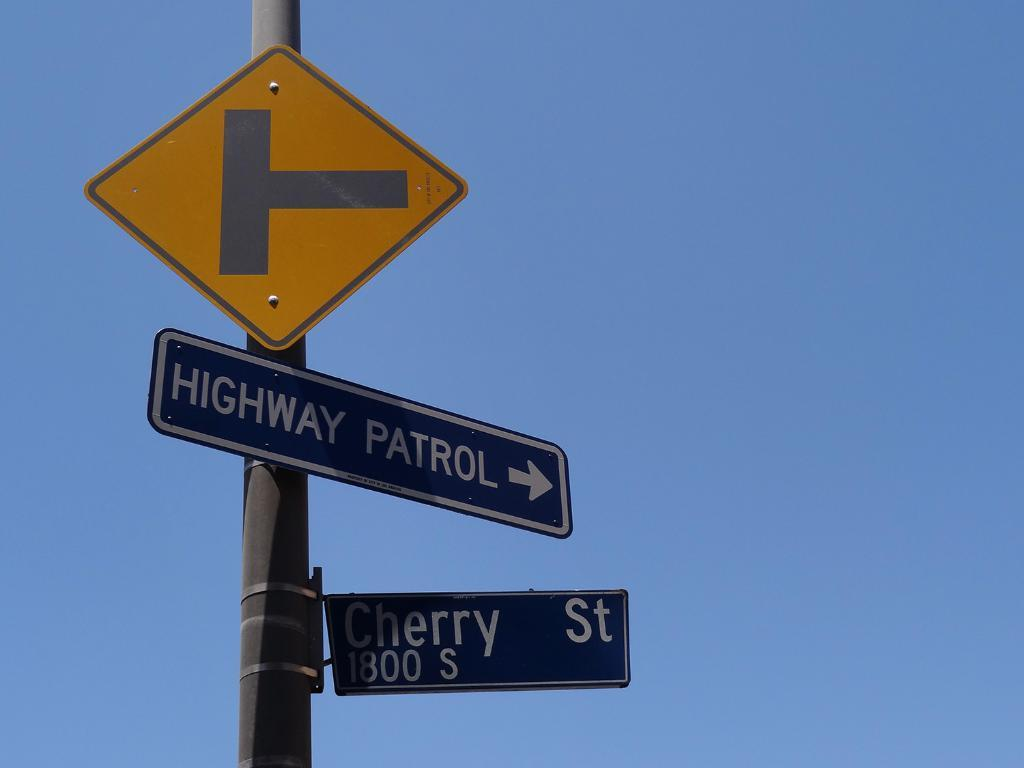<image>
Summarize the visual content of the image. You are on Cherry Street, if you need the Highway Patrol Turn Right. 